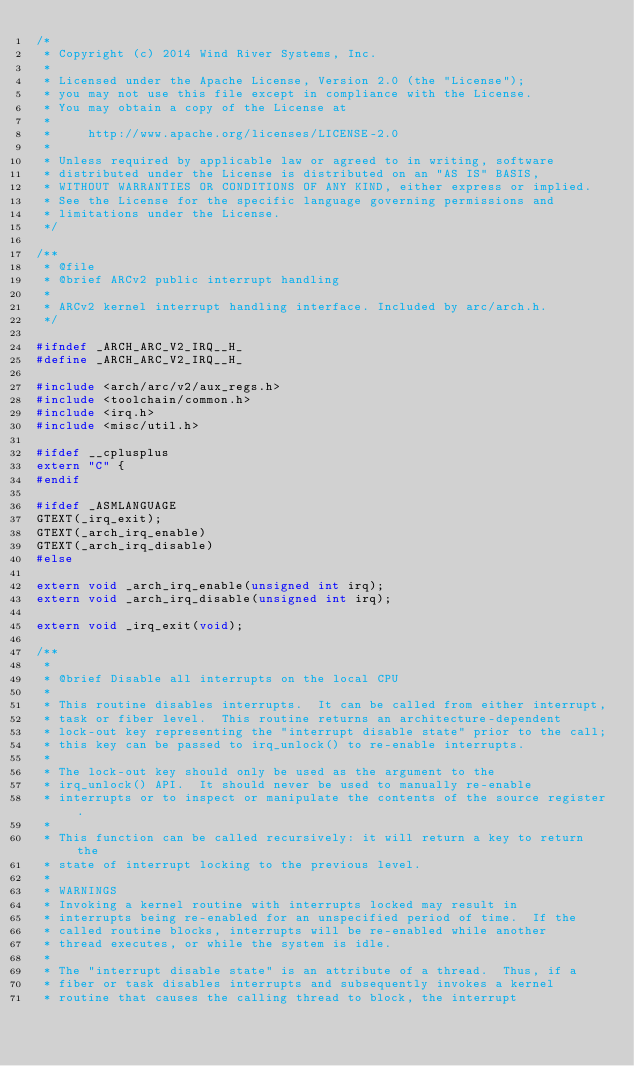Convert code to text. <code><loc_0><loc_0><loc_500><loc_500><_C_>/*
 * Copyright (c) 2014 Wind River Systems, Inc.
 *
 * Licensed under the Apache License, Version 2.0 (the "License");
 * you may not use this file except in compliance with the License.
 * You may obtain a copy of the License at
 *
 *     http://www.apache.org/licenses/LICENSE-2.0
 *
 * Unless required by applicable law or agreed to in writing, software
 * distributed under the License is distributed on an "AS IS" BASIS,
 * WITHOUT WARRANTIES OR CONDITIONS OF ANY KIND, either express or implied.
 * See the License for the specific language governing permissions and
 * limitations under the License.
 */

/**
 * @file
 * @brief ARCv2 public interrupt handling
 *
 * ARCv2 kernel interrupt handling interface. Included by arc/arch.h.
 */

#ifndef _ARCH_ARC_V2_IRQ__H_
#define _ARCH_ARC_V2_IRQ__H_

#include <arch/arc/v2/aux_regs.h>
#include <toolchain/common.h>
#include <irq.h>
#include <misc/util.h>

#ifdef __cplusplus
extern "C" {
#endif

#ifdef _ASMLANGUAGE
GTEXT(_irq_exit);
GTEXT(_arch_irq_enable)
GTEXT(_arch_irq_disable)
#else

extern void _arch_irq_enable(unsigned int irq);
extern void _arch_irq_disable(unsigned int irq);

extern void _irq_exit(void);

/**
 *
 * @brief Disable all interrupts on the local CPU
 *
 * This routine disables interrupts.  It can be called from either interrupt,
 * task or fiber level.  This routine returns an architecture-dependent
 * lock-out key representing the "interrupt disable state" prior to the call;
 * this key can be passed to irq_unlock() to re-enable interrupts.
 *
 * The lock-out key should only be used as the argument to the
 * irq_unlock() API.  It should never be used to manually re-enable
 * interrupts or to inspect or manipulate the contents of the source register.
 *
 * This function can be called recursively: it will return a key to return the
 * state of interrupt locking to the previous level.
 *
 * WARNINGS
 * Invoking a kernel routine with interrupts locked may result in
 * interrupts being re-enabled for an unspecified period of time.  If the
 * called routine blocks, interrupts will be re-enabled while another
 * thread executes, or while the system is idle.
 *
 * The "interrupt disable state" is an attribute of a thread.  Thus, if a
 * fiber or task disables interrupts and subsequently invokes a kernel
 * routine that causes the calling thread to block, the interrupt</code> 